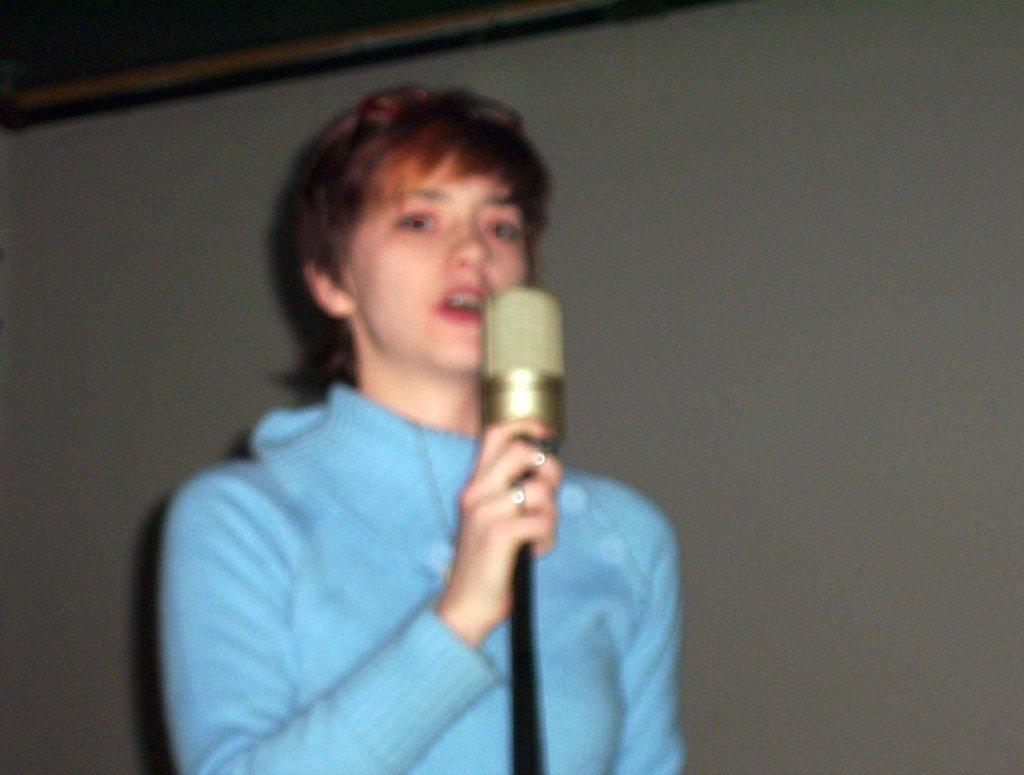Who is the main subject in the image? There is a woman in the image. What is the woman doing in the image? The woman is standing and holding a mic. What is the woman wearing in the image? The woman is wearing a blue top. How does the woman push the moon in the image? There is no moon present in the image, and the woman is not pushing anything. 